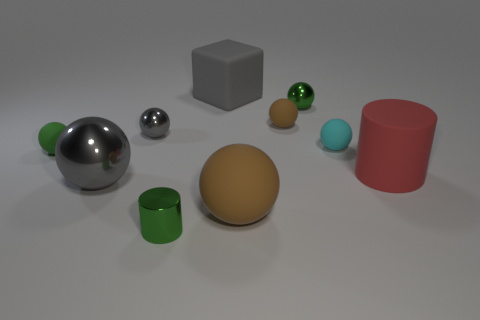Do the large matte ball and the small rubber ball that is behind the cyan matte object have the same color?
Make the answer very short. Yes. What number of spheres are gray things or cyan matte things?
Ensure brevity in your answer.  3. Is there any other thing that is the same color as the big matte cylinder?
Provide a short and direct response. No. What is the material of the large gray object that is in front of the tiny green sphere on the right side of the gray rubber block?
Your answer should be very brief. Metal. Do the small gray thing and the large gray thing behind the cyan thing have the same material?
Provide a short and direct response. No. What number of objects are either large objects right of the green shiny cylinder or shiny things?
Your response must be concise. 7. Is there another metal cylinder of the same color as the metal cylinder?
Your answer should be compact. No. Do the tiny cyan matte thing and the small green shiny object behind the large brown ball have the same shape?
Provide a succinct answer. Yes. What number of spheres are behind the red cylinder and left of the cyan matte object?
Ensure brevity in your answer.  4. What material is the small cyan thing that is the same shape as the small gray shiny object?
Keep it short and to the point. Rubber. 